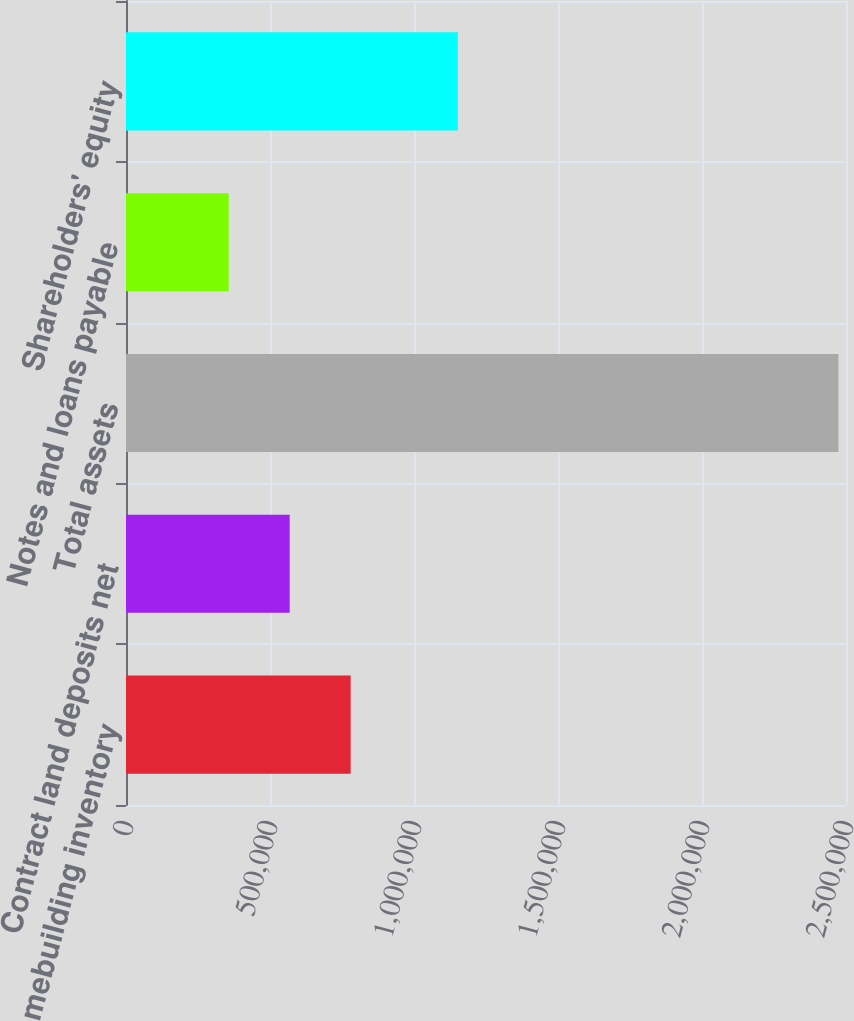Convert chart to OTSL. <chart><loc_0><loc_0><loc_500><loc_500><bar_chart><fcel>Homebuilding inventory<fcel>Contract land deposits net<fcel>Total assets<fcel>Notes and loans payable<fcel>Shareholders' equity<nl><fcel>780067<fcel>568350<fcel>2.47381e+06<fcel>356632<fcel>1.15207e+06<nl></chart> 